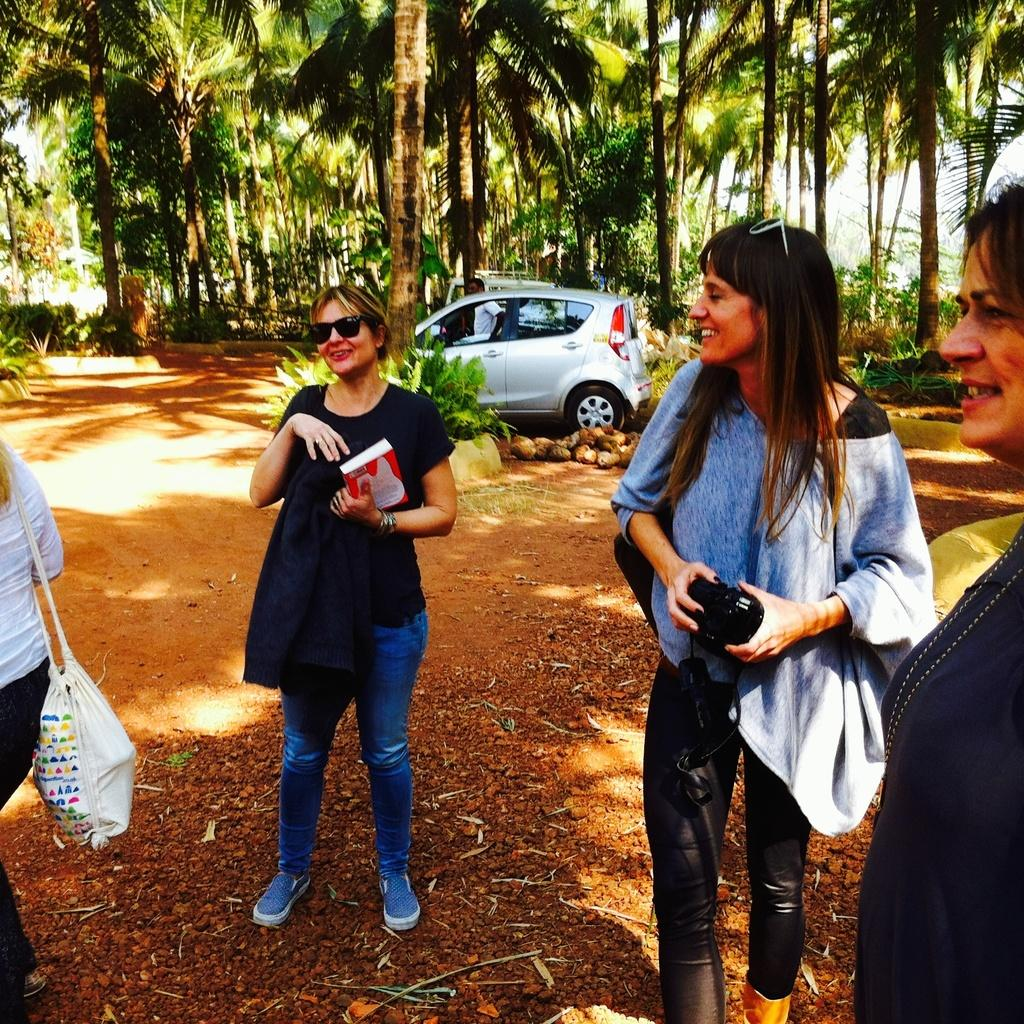What is happening in the image? There are people standing on a land in the image. What can be seen in the background of the image? There is a car and trees in the background of the image. How many pizzas are being served by the cat in the wilderness in the image? There is no cat or pizzas present in the image, and it does not depict a wilderness setting. 